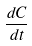Convert formula to latex. <formula><loc_0><loc_0><loc_500><loc_500>\frac { d C } { d t }</formula> 